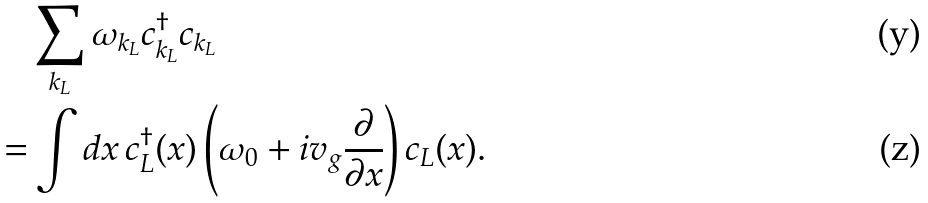Convert formula to latex. <formula><loc_0><loc_0><loc_500><loc_500>& \sum _ { k _ { L } } \omega _ { k _ { L } } c _ { k _ { L } } ^ { \dagger } c _ { k _ { L } } \\ = & \int d x \, c _ { L } ^ { \dagger } ( x ) \left ( \omega _ { 0 } + i v _ { g } \frac { \partial } { \partial x } \right ) c _ { L } ( x ) .</formula> 